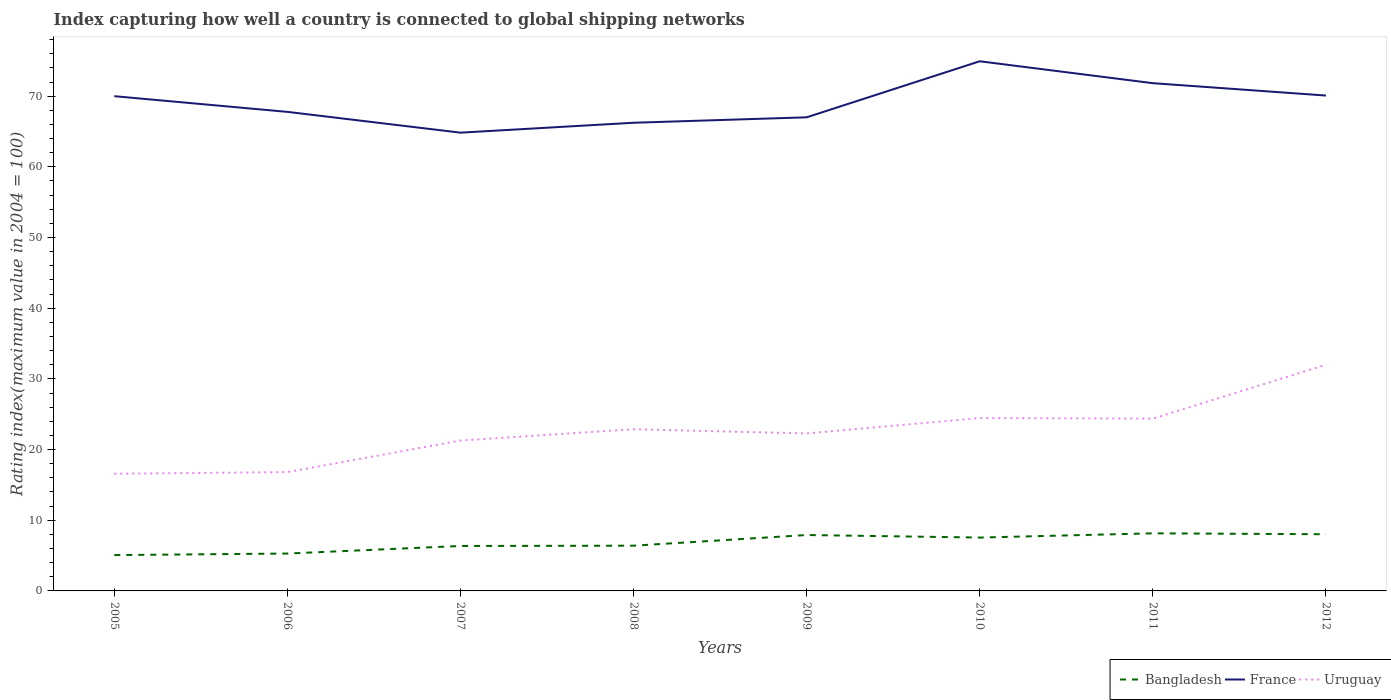Does the line corresponding to Bangladesh intersect with the line corresponding to Uruguay?
Your response must be concise. No. Across all years, what is the maximum rating index in France?
Your response must be concise. 64.84. In which year was the rating index in Bangladesh maximum?
Provide a short and direct response. 2005. What is the total rating index in France in the graph?
Provide a succinct answer. -7. What is the difference between the highest and the second highest rating index in Bangladesh?
Your answer should be compact. 3.08. How many years are there in the graph?
Your answer should be very brief. 8. Are the values on the major ticks of Y-axis written in scientific E-notation?
Keep it short and to the point. No. Does the graph contain any zero values?
Provide a short and direct response. No. Does the graph contain grids?
Provide a short and direct response. No. How many legend labels are there?
Your answer should be compact. 3. How are the legend labels stacked?
Offer a very short reply. Horizontal. What is the title of the graph?
Keep it short and to the point. Index capturing how well a country is connected to global shipping networks. What is the label or title of the X-axis?
Your answer should be very brief. Years. What is the label or title of the Y-axis?
Ensure brevity in your answer.  Rating index(maximum value in 2004 = 100). What is the Rating index(maximum value in 2004 = 100) in Bangladesh in 2005?
Make the answer very short. 5.07. What is the Rating index(maximum value in 2004 = 100) of Uruguay in 2005?
Give a very brief answer. 16.58. What is the Rating index(maximum value in 2004 = 100) in Bangladesh in 2006?
Keep it short and to the point. 5.29. What is the Rating index(maximum value in 2004 = 100) in France in 2006?
Your answer should be very brief. 67.78. What is the Rating index(maximum value in 2004 = 100) in Uruguay in 2006?
Your answer should be compact. 16.81. What is the Rating index(maximum value in 2004 = 100) of Bangladesh in 2007?
Give a very brief answer. 6.36. What is the Rating index(maximum value in 2004 = 100) of France in 2007?
Ensure brevity in your answer.  64.84. What is the Rating index(maximum value in 2004 = 100) of Uruguay in 2007?
Your answer should be very brief. 21.28. What is the Rating index(maximum value in 2004 = 100) of Bangladesh in 2008?
Ensure brevity in your answer.  6.4. What is the Rating index(maximum value in 2004 = 100) in France in 2008?
Give a very brief answer. 66.24. What is the Rating index(maximum value in 2004 = 100) in Uruguay in 2008?
Ensure brevity in your answer.  22.88. What is the Rating index(maximum value in 2004 = 100) of Bangladesh in 2009?
Your answer should be very brief. 7.91. What is the Rating index(maximum value in 2004 = 100) in France in 2009?
Your response must be concise. 67.01. What is the Rating index(maximum value in 2004 = 100) of Uruguay in 2009?
Give a very brief answer. 22.28. What is the Rating index(maximum value in 2004 = 100) in Bangladesh in 2010?
Your response must be concise. 7.55. What is the Rating index(maximum value in 2004 = 100) in France in 2010?
Your response must be concise. 74.94. What is the Rating index(maximum value in 2004 = 100) in Uruguay in 2010?
Your answer should be very brief. 24.46. What is the Rating index(maximum value in 2004 = 100) in Bangladesh in 2011?
Your answer should be very brief. 8.15. What is the Rating index(maximum value in 2004 = 100) of France in 2011?
Your answer should be very brief. 71.84. What is the Rating index(maximum value in 2004 = 100) of Uruguay in 2011?
Keep it short and to the point. 24.38. What is the Rating index(maximum value in 2004 = 100) of Bangladesh in 2012?
Give a very brief answer. 8.02. What is the Rating index(maximum value in 2004 = 100) in France in 2012?
Offer a terse response. 70.09. Across all years, what is the maximum Rating index(maximum value in 2004 = 100) in Bangladesh?
Give a very brief answer. 8.15. Across all years, what is the maximum Rating index(maximum value in 2004 = 100) in France?
Provide a short and direct response. 74.94. Across all years, what is the maximum Rating index(maximum value in 2004 = 100) in Uruguay?
Make the answer very short. 32. Across all years, what is the minimum Rating index(maximum value in 2004 = 100) of Bangladesh?
Give a very brief answer. 5.07. Across all years, what is the minimum Rating index(maximum value in 2004 = 100) in France?
Offer a very short reply. 64.84. Across all years, what is the minimum Rating index(maximum value in 2004 = 100) in Uruguay?
Give a very brief answer. 16.58. What is the total Rating index(maximum value in 2004 = 100) in Bangladesh in the graph?
Keep it short and to the point. 54.75. What is the total Rating index(maximum value in 2004 = 100) in France in the graph?
Provide a short and direct response. 552.74. What is the total Rating index(maximum value in 2004 = 100) in Uruguay in the graph?
Offer a terse response. 180.67. What is the difference between the Rating index(maximum value in 2004 = 100) in Bangladesh in 2005 and that in 2006?
Offer a very short reply. -0.22. What is the difference between the Rating index(maximum value in 2004 = 100) of France in 2005 and that in 2006?
Provide a succinct answer. 2.22. What is the difference between the Rating index(maximum value in 2004 = 100) in Uruguay in 2005 and that in 2006?
Make the answer very short. -0.23. What is the difference between the Rating index(maximum value in 2004 = 100) of Bangladesh in 2005 and that in 2007?
Your response must be concise. -1.29. What is the difference between the Rating index(maximum value in 2004 = 100) of France in 2005 and that in 2007?
Offer a very short reply. 5.16. What is the difference between the Rating index(maximum value in 2004 = 100) in Bangladesh in 2005 and that in 2008?
Offer a terse response. -1.33. What is the difference between the Rating index(maximum value in 2004 = 100) of France in 2005 and that in 2008?
Your answer should be compact. 3.76. What is the difference between the Rating index(maximum value in 2004 = 100) in Uruguay in 2005 and that in 2008?
Provide a short and direct response. -6.3. What is the difference between the Rating index(maximum value in 2004 = 100) in Bangladesh in 2005 and that in 2009?
Keep it short and to the point. -2.84. What is the difference between the Rating index(maximum value in 2004 = 100) of France in 2005 and that in 2009?
Give a very brief answer. 2.99. What is the difference between the Rating index(maximum value in 2004 = 100) of Bangladesh in 2005 and that in 2010?
Your answer should be compact. -2.48. What is the difference between the Rating index(maximum value in 2004 = 100) in France in 2005 and that in 2010?
Your answer should be compact. -4.94. What is the difference between the Rating index(maximum value in 2004 = 100) in Uruguay in 2005 and that in 2010?
Keep it short and to the point. -7.88. What is the difference between the Rating index(maximum value in 2004 = 100) of Bangladesh in 2005 and that in 2011?
Make the answer very short. -3.08. What is the difference between the Rating index(maximum value in 2004 = 100) in France in 2005 and that in 2011?
Keep it short and to the point. -1.84. What is the difference between the Rating index(maximum value in 2004 = 100) of Uruguay in 2005 and that in 2011?
Give a very brief answer. -7.8. What is the difference between the Rating index(maximum value in 2004 = 100) of Bangladesh in 2005 and that in 2012?
Offer a very short reply. -2.95. What is the difference between the Rating index(maximum value in 2004 = 100) of France in 2005 and that in 2012?
Your answer should be compact. -0.09. What is the difference between the Rating index(maximum value in 2004 = 100) of Uruguay in 2005 and that in 2012?
Offer a very short reply. -15.42. What is the difference between the Rating index(maximum value in 2004 = 100) in Bangladesh in 2006 and that in 2007?
Make the answer very short. -1.07. What is the difference between the Rating index(maximum value in 2004 = 100) in France in 2006 and that in 2007?
Offer a terse response. 2.94. What is the difference between the Rating index(maximum value in 2004 = 100) of Uruguay in 2006 and that in 2007?
Your response must be concise. -4.47. What is the difference between the Rating index(maximum value in 2004 = 100) of Bangladesh in 2006 and that in 2008?
Provide a short and direct response. -1.11. What is the difference between the Rating index(maximum value in 2004 = 100) of France in 2006 and that in 2008?
Your answer should be very brief. 1.54. What is the difference between the Rating index(maximum value in 2004 = 100) of Uruguay in 2006 and that in 2008?
Your response must be concise. -6.07. What is the difference between the Rating index(maximum value in 2004 = 100) of Bangladesh in 2006 and that in 2009?
Ensure brevity in your answer.  -2.62. What is the difference between the Rating index(maximum value in 2004 = 100) in France in 2006 and that in 2009?
Your answer should be compact. 0.77. What is the difference between the Rating index(maximum value in 2004 = 100) in Uruguay in 2006 and that in 2009?
Offer a terse response. -5.47. What is the difference between the Rating index(maximum value in 2004 = 100) of Bangladesh in 2006 and that in 2010?
Make the answer very short. -2.26. What is the difference between the Rating index(maximum value in 2004 = 100) in France in 2006 and that in 2010?
Provide a short and direct response. -7.16. What is the difference between the Rating index(maximum value in 2004 = 100) of Uruguay in 2006 and that in 2010?
Keep it short and to the point. -7.65. What is the difference between the Rating index(maximum value in 2004 = 100) of Bangladesh in 2006 and that in 2011?
Offer a terse response. -2.86. What is the difference between the Rating index(maximum value in 2004 = 100) in France in 2006 and that in 2011?
Ensure brevity in your answer.  -4.06. What is the difference between the Rating index(maximum value in 2004 = 100) in Uruguay in 2006 and that in 2011?
Your response must be concise. -7.57. What is the difference between the Rating index(maximum value in 2004 = 100) of Bangladesh in 2006 and that in 2012?
Make the answer very short. -2.73. What is the difference between the Rating index(maximum value in 2004 = 100) in France in 2006 and that in 2012?
Ensure brevity in your answer.  -2.31. What is the difference between the Rating index(maximum value in 2004 = 100) of Uruguay in 2006 and that in 2012?
Give a very brief answer. -15.19. What is the difference between the Rating index(maximum value in 2004 = 100) in Bangladesh in 2007 and that in 2008?
Your response must be concise. -0.04. What is the difference between the Rating index(maximum value in 2004 = 100) in France in 2007 and that in 2008?
Keep it short and to the point. -1.4. What is the difference between the Rating index(maximum value in 2004 = 100) of Uruguay in 2007 and that in 2008?
Your answer should be compact. -1.6. What is the difference between the Rating index(maximum value in 2004 = 100) in Bangladesh in 2007 and that in 2009?
Provide a succinct answer. -1.55. What is the difference between the Rating index(maximum value in 2004 = 100) in France in 2007 and that in 2009?
Your answer should be compact. -2.17. What is the difference between the Rating index(maximum value in 2004 = 100) in Bangladesh in 2007 and that in 2010?
Offer a terse response. -1.19. What is the difference between the Rating index(maximum value in 2004 = 100) in France in 2007 and that in 2010?
Offer a very short reply. -10.1. What is the difference between the Rating index(maximum value in 2004 = 100) in Uruguay in 2007 and that in 2010?
Keep it short and to the point. -3.18. What is the difference between the Rating index(maximum value in 2004 = 100) of Bangladesh in 2007 and that in 2011?
Your response must be concise. -1.79. What is the difference between the Rating index(maximum value in 2004 = 100) in Bangladesh in 2007 and that in 2012?
Give a very brief answer. -1.66. What is the difference between the Rating index(maximum value in 2004 = 100) in France in 2007 and that in 2012?
Your answer should be compact. -5.25. What is the difference between the Rating index(maximum value in 2004 = 100) in Uruguay in 2007 and that in 2012?
Ensure brevity in your answer.  -10.72. What is the difference between the Rating index(maximum value in 2004 = 100) of Bangladesh in 2008 and that in 2009?
Give a very brief answer. -1.51. What is the difference between the Rating index(maximum value in 2004 = 100) of France in 2008 and that in 2009?
Make the answer very short. -0.77. What is the difference between the Rating index(maximum value in 2004 = 100) of Bangladesh in 2008 and that in 2010?
Make the answer very short. -1.15. What is the difference between the Rating index(maximum value in 2004 = 100) of Uruguay in 2008 and that in 2010?
Offer a very short reply. -1.58. What is the difference between the Rating index(maximum value in 2004 = 100) in Bangladesh in 2008 and that in 2011?
Provide a succinct answer. -1.75. What is the difference between the Rating index(maximum value in 2004 = 100) in Uruguay in 2008 and that in 2011?
Offer a terse response. -1.5. What is the difference between the Rating index(maximum value in 2004 = 100) of Bangladesh in 2008 and that in 2012?
Offer a very short reply. -1.62. What is the difference between the Rating index(maximum value in 2004 = 100) in France in 2008 and that in 2012?
Keep it short and to the point. -3.85. What is the difference between the Rating index(maximum value in 2004 = 100) of Uruguay in 2008 and that in 2012?
Keep it short and to the point. -9.12. What is the difference between the Rating index(maximum value in 2004 = 100) of Bangladesh in 2009 and that in 2010?
Your answer should be very brief. 0.36. What is the difference between the Rating index(maximum value in 2004 = 100) of France in 2009 and that in 2010?
Ensure brevity in your answer.  -7.93. What is the difference between the Rating index(maximum value in 2004 = 100) in Uruguay in 2009 and that in 2010?
Offer a very short reply. -2.18. What is the difference between the Rating index(maximum value in 2004 = 100) in Bangladesh in 2009 and that in 2011?
Your response must be concise. -0.24. What is the difference between the Rating index(maximum value in 2004 = 100) in France in 2009 and that in 2011?
Your answer should be very brief. -4.83. What is the difference between the Rating index(maximum value in 2004 = 100) in Bangladesh in 2009 and that in 2012?
Your answer should be very brief. -0.11. What is the difference between the Rating index(maximum value in 2004 = 100) in France in 2009 and that in 2012?
Your response must be concise. -3.08. What is the difference between the Rating index(maximum value in 2004 = 100) of Uruguay in 2009 and that in 2012?
Give a very brief answer. -9.72. What is the difference between the Rating index(maximum value in 2004 = 100) of Bangladesh in 2010 and that in 2011?
Keep it short and to the point. -0.6. What is the difference between the Rating index(maximum value in 2004 = 100) of France in 2010 and that in 2011?
Ensure brevity in your answer.  3.1. What is the difference between the Rating index(maximum value in 2004 = 100) of Bangladesh in 2010 and that in 2012?
Ensure brevity in your answer.  -0.47. What is the difference between the Rating index(maximum value in 2004 = 100) of France in 2010 and that in 2012?
Provide a succinct answer. 4.85. What is the difference between the Rating index(maximum value in 2004 = 100) of Uruguay in 2010 and that in 2012?
Provide a succinct answer. -7.54. What is the difference between the Rating index(maximum value in 2004 = 100) of Bangladesh in 2011 and that in 2012?
Provide a short and direct response. 0.13. What is the difference between the Rating index(maximum value in 2004 = 100) in France in 2011 and that in 2012?
Ensure brevity in your answer.  1.75. What is the difference between the Rating index(maximum value in 2004 = 100) of Uruguay in 2011 and that in 2012?
Offer a terse response. -7.62. What is the difference between the Rating index(maximum value in 2004 = 100) in Bangladesh in 2005 and the Rating index(maximum value in 2004 = 100) in France in 2006?
Make the answer very short. -62.71. What is the difference between the Rating index(maximum value in 2004 = 100) of Bangladesh in 2005 and the Rating index(maximum value in 2004 = 100) of Uruguay in 2006?
Offer a very short reply. -11.74. What is the difference between the Rating index(maximum value in 2004 = 100) of France in 2005 and the Rating index(maximum value in 2004 = 100) of Uruguay in 2006?
Your answer should be compact. 53.19. What is the difference between the Rating index(maximum value in 2004 = 100) of Bangladesh in 2005 and the Rating index(maximum value in 2004 = 100) of France in 2007?
Make the answer very short. -59.77. What is the difference between the Rating index(maximum value in 2004 = 100) of Bangladesh in 2005 and the Rating index(maximum value in 2004 = 100) of Uruguay in 2007?
Your response must be concise. -16.21. What is the difference between the Rating index(maximum value in 2004 = 100) in France in 2005 and the Rating index(maximum value in 2004 = 100) in Uruguay in 2007?
Your answer should be very brief. 48.72. What is the difference between the Rating index(maximum value in 2004 = 100) of Bangladesh in 2005 and the Rating index(maximum value in 2004 = 100) of France in 2008?
Offer a terse response. -61.17. What is the difference between the Rating index(maximum value in 2004 = 100) in Bangladesh in 2005 and the Rating index(maximum value in 2004 = 100) in Uruguay in 2008?
Make the answer very short. -17.81. What is the difference between the Rating index(maximum value in 2004 = 100) of France in 2005 and the Rating index(maximum value in 2004 = 100) of Uruguay in 2008?
Provide a short and direct response. 47.12. What is the difference between the Rating index(maximum value in 2004 = 100) in Bangladesh in 2005 and the Rating index(maximum value in 2004 = 100) in France in 2009?
Offer a terse response. -61.94. What is the difference between the Rating index(maximum value in 2004 = 100) of Bangladesh in 2005 and the Rating index(maximum value in 2004 = 100) of Uruguay in 2009?
Give a very brief answer. -17.21. What is the difference between the Rating index(maximum value in 2004 = 100) of France in 2005 and the Rating index(maximum value in 2004 = 100) of Uruguay in 2009?
Provide a succinct answer. 47.72. What is the difference between the Rating index(maximum value in 2004 = 100) in Bangladesh in 2005 and the Rating index(maximum value in 2004 = 100) in France in 2010?
Offer a very short reply. -69.87. What is the difference between the Rating index(maximum value in 2004 = 100) of Bangladesh in 2005 and the Rating index(maximum value in 2004 = 100) of Uruguay in 2010?
Offer a very short reply. -19.39. What is the difference between the Rating index(maximum value in 2004 = 100) in France in 2005 and the Rating index(maximum value in 2004 = 100) in Uruguay in 2010?
Ensure brevity in your answer.  45.54. What is the difference between the Rating index(maximum value in 2004 = 100) in Bangladesh in 2005 and the Rating index(maximum value in 2004 = 100) in France in 2011?
Offer a terse response. -66.77. What is the difference between the Rating index(maximum value in 2004 = 100) of Bangladesh in 2005 and the Rating index(maximum value in 2004 = 100) of Uruguay in 2011?
Keep it short and to the point. -19.31. What is the difference between the Rating index(maximum value in 2004 = 100) in France in 2005 and the Rating index(maximum value in 2004 = 100) in Uruguay in 2011?
Your response must be concise. 45.62. What is the difference between the Rating index(maximum value in 2004 = 100) in Bangladesh in 2005 and the Rating index(maximum value in 2004 = 100) in France in 2012?
Provide a succinct answer. -65.02. What is the difference between the Rating index(maximum value in 2004 = 100) of Bangladesh in 2005 and the Rating index(maximum value in 2004 = 100) of Uruguay in 2012?
Your answer should be compact. -26.93. What is the difference between the Rating index(maximum value in 2004 = 100) of Bangladesh in 2006 and the Rating index(maximum value in 2004 = 100) of France in 2007?
Provide a short and direct response. -59.55. What is the difference between the Rating index(maximum value in 2004 = 100) of Bangladesh in 2006 and the Rating index(maximum value in 2004 = 100) of Uruguay in 2007?
Ensure brevity in your answer.  -15.99. What is the difference between the Rating index(maximum value in 2004 = 100) of France in 2006 and the Rating index(maximum value in 2004 = 100) of Uruguay in 2007?
Provide a short and direct response. 46.5. What is the difference between the Rating index(maximum value in 2004 = 100) of Bangladesh in 2006 and the Rating index(maximum value in 2004 = 100) of France in 2008?
Ensure brevity in your answer.  -60.95. What is the difference between the Rating index(maximum value in 2004 = 100) of Bangladesh in 2006 and the Rating index(maximum value in 2004 = 100) of Uruguay in 2008?
Ensure brevity in your answer.  -17.59. What is the difference between the Rating index(maximum value in 2004 = 100) of France in 2006 and the Rating index(maximum value in 2004 = 100) of Uruguay in 2008?
Ensure brevity in your answer.  44.9. What is the difference between the Rating index(maximum value in 2004 = 100) of Bangladesh in 2006 and the Rating index(maximum value in 2004 = 100) of France in 2009?
Make the answer very short. -61.72. What is the difference between the Rating index(maximum value in 2004 = 100) in Bangladesh in 2006 and the Rating index(maximum value in 2004 = 100) in Uruguay in 2009?
Give a very brief answer. -16.99. What is the difference between the Rating index(maximum value in 2004 = 100) of France in 2006 and the Rating index(maximum value in 2004 = 100) of Uruguay in 2009?
Ensure brevity in your answer.  45.5. What is the difference between the Rating index(maximum value in 2004 = 100) in Bangladesh in 2006 and the Rating index(maximum value in 2004 = 100) in France in 2010?
Provide a short and direct response. -69.65. What is the difference between the Rating index(maximum value in 2004 = 100) in Bangladesh in 2006 and the Rating index(maximum value in 2004 = 100) in Uruguay in 2010?
Give a very brief answer. -19.17. What is the difference between the Rating index(maximum value in 2004 = 100) in France in 2006 and the Rating index(maximum value in 2004 = 100) in Uruguay in 2010?
Give a very brief answer. 43.32. What is the difference between the Rating index(maximum value in 2004 = 100) of Bangladesh in 2006 and the Rating index(maximum value in 2004 = 100) of France in 2011?
Make the answer very short. -66.55. What is the difference between the Rating index(maximum value in 2004 = 100) of Bangladesh in 2006 and the Rating index(maximum value in 2004 = 100) of Uruguay in 2011?
Your answer should be compact. -19.09. What is the difference between the Rating index(maximum value in 2004 = 100) of France in 2006 and the Rating index(maximum value in 2004 = 100) of Uruguay in 2011?
Provide a succinct answer. 43.4. What is the difference between the Rating index(maximum value in 2004 = 100) of Bangladesh in 2006 and the Rating index(maximum value in 2004 = 100) of France in 2012?
Your answer should be very brief. -64.8. What is the difference between the Rating index(maximum value in 2004 = 100) in Bangladesh in 2006 and the Rating index(maximum value in 2004 = 100) in Uruguay in 2012?
Provide a succinct answer. -26.71. What is the difference between the Rating index(maximum value in 2004 = 100) of France in 2006 and the Rating index(maximum value in 2004 = 100) of Uruguay in 2012?
Keep it short and to the point. 35.78. What is the difference between the Rating index(maximum value in 2004 = 100) of Bangladesh in 2007 and the Rating index(maximum value in 2004 = 100) of France in 2008?
Provide a succinct answer. -59.88. What is the difference between the Rating index(maximum value in 2004 = 100) of Bangladesh in 2007 and the Rating index(maximum value in 2004 = 100) of Uruguay in 2008?
Provide a succinct answer. -16.52. What is the difference between the Rating index(maximum value in 2004 = 100) of France in 2007 and the Rating index(maximum value in 2004 = 100) of Uruguay in 2008?
Keep it short and to the point. 41.96. What is the difference between the Rating index(maximum value in 2004 = 100) of Bangladesh in 2007 and the Rating index(maximum value in 2004 = 100) of France in 2009?
Your answer should be very brief. -60.65. What is the difference between the Rating index(maximum value in 2004 = 100) of Bangladesh in 2007 and the Rating index(maximum value in 2004 = 100) of Uruguay in 2009?
Offer a terse response. -15.92. What is the difference between the Rating index(maximum value in 2004 = 100) in France in 2007 and the Rating index(maximum value in 2004 = 100) in Uruguay in 2009?
Ensure brevity in your answer.  42.56. What is the difference between the Rating index(maximum value in 2004 = 100) of Bangladesh in 2007 and the Rating index(maximum value in 2004 = 100) of France in 2010?
Give a very brief answer. -68.58. What is the difference between the Rating index(maximum value in 2004 = 100) in Bangladesh in 2007 and the Rating index(maximum value in 2004 = 100) in Uruguay in 2010?
Offer a terse response. -18.1. What is the difference between the Rating index(maximum value in 2004 = 100) of France in 2007 and the Rating index(maximum value in 2004 = 100) of Uruguay in 2010?
Offer a very short reply. 40.38. What is the difference between the Rating index(maximum value in 2004 = 100) in Bangladesh in 2007 and the Rating index(maximum value in 2004 = 100) in France in 2011?
Offer a terse response. -65.48. What is the difference between the Rating index(maximum value in 2004 = 100) of Bangladesh in 2007 and the Rating index(maximum value in 2004 = 100) of Uruguay in 2011?
Provide a succinct answer. -18.02. What is the difference between the Rating index(maximum value in 2004 = 100) in France in 2007 and the Rating index(maximum value in 2004 = 100) in Uruguay in 2011?
Provide a succinct answer. 40.46. What is the difference between the Rating index(maximum value in 2004 = 100) of Bangladesh in 2007 and the Rating index(maximum value in 2004 = 100) of France in 2012?
Your response must be concise. -63.73. What is the difference between the Rating index(maximum value in 2004 = 100) in Bangladesh in 2007 and the Rating index(maximum value in 2004 = 100) in Uruguay in 2012?
Make the answer very short. -25.64. What is the difference between the Rating index(maximum value in 2004 = 100) of France in 2007 and the Rating index(maximum value in 2004 = 100) of Uruguay in 2012?
Your answer should be compact. 32.84. What is the difference between the Rating index(maximum value in 2004 = 100) in Bangladesh in 2008 and the Rating index(maximum value in 2004 = 100) in France in 2009?
Your response must be concise. -60.61. What is the difference between the Rating index(maximum value in 2004 = 100) in Bangladesh in 2008 and the Rating index(maximum value in 2004 = 100) in Uruguay in 2009?
Provide a short and direct response. -15.88. What is the difference between the Rating index(maximum value in 2004 = 100) of France in 2008 and the Rating index(maximum value in 2004 = 100) of Uruguay in 2009?
Keep it short and to the point. 43.96. What is the difference between the Rating index(maximum value in 2004 = 100) in Bangladesh in 2008 and the Rating index(maximum value in 2004 = 100) in France in 2010?
Keep it short and to the point. -68.54. What is the difference between the Rating index(maximum value in 2004 = 100) of Bangladesh in 2008 and the Rating index(maximum value in 2004 = 100) of Uruguay in 2010?
Provide a short and direct response. -18.06. What is the difference between the Rating index(maximum value in 2004 = 100) in France in 2008 and the Rating index(maximum value in 2004 = 100) in Uruguay in 2010?
Ensure brevity in your answer.  41.78. What is the difference between the Rating index(maximum value in 2004 = 100) in Bangladesh in 2008 and the Rating index(maximum value in 2004 = 100) in France in 2011?
Provide a short and direct response. -65.44. What is the difference between the Rating index(maximum value in 2004 = 100) in Bangladesh in 2008 and the Rating index(maximum value in 2004 = 100) in Uruguay in 2011?
Your answer should be very brief. -17.98. What is the difference between the Rating index(maximum value in 2004 = 100) in France in 2008 and the Rating index(maximum value in 2004 = 100) in Uruguay in 2011?
Your answer should be very brief. 41.86. What is the difference between the Rating index(maximum value in 2004 = 100) in Bangladesh in 2008 and the Rating index(maximum value in 2004 = 100) in France in 2012?
Ensure brevity in your answer.  -63.69. What is the difference between the Rating index(maximum value in 2004 = 100) of Bangladesh in 2008 and the Rating index(maximum value in 2004 = 100) of Uruguay in 2012?
Give a very brief answer. -25.6. What is the difference between the Rating index(maximum value in 2004 = 100) in France in 2008 and the Rating index(maximum value in 2004 = 100) in Uruguay in 2012?
Ensure brevity in your answer.  34.24. What is the difference between the Rating index(maximum value in 2004 = 100) in Bangladesh in 2009 and the Rating index(maximum value in 2004 = 100) in France in 2010?
Offer a very short reply. -67.03. What is the difference between the Rating index(maximum value in 2004 = 100) of Bangladesh in 2009 and the Rating index(maximum value in 2004 = 100) of Uruguay in 2010?
Your response must be concise. -16.55. What is the difference between the Rating index(maximum value in 2004 = 100) of France in 2009 and the Rating index(maximum value in 2004 = 100) of Uruguay in 2010?
Offer a terse response. 42.55. What is the difference between the Rating index(maximum value in 2004 = 100) in Bangladesh in 2009 and the Rating index(maximum value in 2004 = 100) in France in 2011?
Your response must be concise. -63.93. What is the difference between the Rating index(maximum value in 2004 = 100) in Bangladesh in 2009 and the Rating index(maximum value in 2004 = 100) in Uruguay in 2011?
Your answer should be very brief. -16.47. What is the difference between the Rating index(maximum value in 2004 = 100) in France in 2009 and the Rating index(maximum value in 2004 = 100) in Uruguay in 2011?
Offer a terse response. 42.63. What is the difference between the Rating index(maximum value in 2004 = 100) in Bangladesh in 2009 and the Rating index(maximum value in 2004 = 100) in France in 2012?
Offer a terse response. -62.18. What is the difference between the Rating index(maximum value in 2004 = 100) of Bangladesh in 2009 and the Rating index(maximum value in 2004 = 100) of Uruguay in 2012?
Make the answer very short. -24.09. What is the difference between the Rating index(maximum value in 2004 = 100) in France in 2009 and the Rating index(maximum value in 2004 = 100) in Uruguay in 2012?
Offer a terse response. 35.01. What is the difference between the Rating index(maximum value in 2004 = 100) of Bangladesh in 2010 and the Rating index(maximum value in 2004 = 100) of France in 2011?
Give a very brief answer. -64.29. What is the difference between the Rating index(maximum value in 2004 = 100) in Bangladesh in 2010 and the Rating index(maximum value in 2004 = 100) in Uruguay in 2011?
Your answer should be compact. -16.83. What is the difference between the Rating index(maximum value in 2004 = 100) of France in 2010 and the Rating index(maximum value in 2004 = 100) of Uruguay in 2011?
Provide a succinct answer. 50.56. What is the difference between the Rating index(maximum value in 2004 = 100) in Bangladesh in 2010 and the Rating index(maximum value in 2004 = 100) in France in 2012?
Offer a very short reply. -62.54. What is the difference between the Rating index(maximum value in 2004 = 100) of Bangladesh in 2010 and the Rating index(maximum value in 2004 = 100) of Uruguay in 2012?
Provide a succinct answer. -24.45. What is the difference between the Rating index(maximum value in 2004 = 100) in France in 2010 and the Rating index(maximum value in 2004 = 100) in Uruguay in 2012?
Keep it short and to the point. 42.94. What is the difference between the Rating index(maximum value in 2004 = 100) in Bangladesh in 2011 and the Rating index(maximum value in 2004 = 100) in France in 2012?
Offer a very short reply. -61.94. What is the difference between the Rating index(maximum value in 2004 = 100) of Bangladesh in 2011 and the Rating index(maximum value in 2004 = 100) of Uruguay in 2012?
Provide a succinct answer. -23.85. What is the difference between the Rating index(maximum value in 2004 = 100) of France in 2011 and the Rating index(maximum value in 2004 = 100) of Uruguay in 2012?
Provide a succinct answer. 39.84. What is the average Rating index(maximum value in 2004 = 100) in Bangladesh per year?
Make the answer very short. 6.84. What is the average Rating index(maximum value in 2004 = 100) in France per year?
Keep it short and to the point. 69.09. What is the average Rating index(maximum value in 2004 = 100) in Uruguay per year?
Offer a very short reply. 22.58. In the year 2005, what is the difference between the Rating index(maximum value in 2004 = 100) in Bangladesh and Rating index(maximum value in 2004 = 100) in France?
Your answer should be compact. -64.93. In the year 2005, what is the difference between the Rating index(maximum value in 2004 = 100) of Bangladesh and Rating index(maximum value in 2004 = 100) of Uruguay?
Ensure brevity in your answer.  -11.51. In the year 2005, what is the difference between the Rating index(maximum value in 2004 = 100) in France and Rating index(maximum value in 2004 = 100) in Uruguay?
Offer a terse response. 53.42. In the year 2006, what is the difference between the Rating index(maximum value in 2004 = 100) of Bangladesh and Rating index(maximum value in 2004 = 100) of France?
Offer a terse response. -62.49. In the year 2006, what is the difference between the Rating index(maximum value in 2004 = 100) of Bangladesh and Rating index(maximum value in 2004 = 100) of Uruguay?
Keep it short and to the point. -11.52. In the year 2006, what is the difference between the Rating index(maximum value in 2004 = 100) of France and Rating index(maximum value in 2004 = 100) of Uruguay?
Ensure brevity in your answer.  50.97. In the year 2007, what is the difference between the Rating index(maximum value in 2004 = 100) of Bangladesh and Rating index(maximum value in 2004 = 100) of France?
Provide a succinct answer. -58.48. In the year 2007, what is the difference between the Rating index(maximum value in 2004 = 100) in Bangladesh and Rating index(maximum value in 2004 = 100) in Uruguay?
Give a very brief answer. -14.92. In the year 2007, what is the difference between the Rating index(maximum value in 2004 = 100) in France and Rating index(maximum value in 2004 = 100) in Uruguay?
Your answer should be compact. 43.56. In the year 2008, what is the difference between the Rating index(maximum value in 2004 = 100) in Bangladesh and Rating index(maximum value in 2004 = 100) in France?
Provide a short and direct response. -59.84. In the year 2008, what is the difference between the Rating index(maximum value in 2004 = 100) of Bangladesh and Rating index(maximum value in 2004 = 100) of Uruguay?
Your answer should be very brief. -16.48. In the year 2008, what is the difference between the Rating index(maximum value in 2004 = 100) in France and Rating index(maximum value in 2004 = 100) in Uruguay?
Your answer should be very brief. 43.36. In the year 2009, what is the difference between the Rating index(maximum value in 2004 = 100) of Bangladesh and Rating index(maximum value in 2004 = 100) of France?
Your answer should be compact. -59.1. In the year 2009, what is the difference between the Rating index(maximum value in 2004 = 100) in Bangladesh and Rating index(maximum value in 2004 = 100) in Uruguay?
Your answer should be compact. -14.37. In the year 2009, what is the difference between the Rating index(maximum value in 2004 = 100) of France and Rating index(maximum value in 2004 = 100) of Uruguay?
Make the answer very short. 44.73. In the year 2010, what is the difference between the Rating index(maximum value in 2004 = 100) of Bangladesh and Rating index(maximum value in 2004 = 100) of France?
Provide a short and direct response. -67.39. In the year 2010, what is the difference between the Rating index(maximum value in 2004 = 100) in Bangladesh and Rating index(maximum value in 2004 = 100) in Uruguay?
Provide a short and direct response. -16.91. In the year 2010, what is the difference between the Rating index(maximum value in 2004 = 100) of France and Rating index(maximum value in 2004 = 100) of Uruguay?
Offer a very short reply. 50.48. In the year 2011, what is the difference between the Rating index(maximum value in 2004 = 100) of Bangladesh and Rating index(maximum value in 2004 = 100) of France?
Ensure brevity in your answer.  -63.69. In the year 2011, what is the difference between the Rating index(maximum value in 2004 = 100) of Bangladesh and Rating index(maximum value in 2004 = 100) of Uruguay?
Your response must be concise. -16.23. In the year 2011, what is the difference between the Rating index(maximum value in 2004 = 100) of France and Rating index(maximum value in 2004 = 100) of Uruguay?
Provide a succinct answer. 47.46. In the year 2012, what is the difference between the Rating index(maximum value in 2004 = 100) of Bangladesh and Rating index(maximum value in 2004 = 100) of France?
Make the answer very short. -62.07. In the year 2012, what is the difference between the Rating index(maximum value in 2004 = 100) in Bangladesh and Rating index(maximum value in 2004 = 100) in Uruguay?
Give a very brief answer. -23.98. In the year 2012, what is the difference between the Rating index(maximum value in 2004 = 100) in France and Rating index(maximum value in 2004 = 100) in Uruguay?
Give a very brief answer. 38.09. What is the ratio of the Rating index(maximum value in 2004 = 100) of Bangladesh in 2005 to that in 2006?
Ensure brevity in your answer.  0.96. What is the ratio of the Rating index(maximum value in 2004 = 100) of France in 2005 to that in 2006?
Provide a succinct answer. 1.03. What is the ratio of the Rating index(maximum value in 2004 = 100) in Uruguay in 2005 to that in 2006?
Provide a succinct answer. 0.99. What is the ratio of the Rating index(maximum value in 2004 = 100) of Bangladesh in 2005 to that in 2007?
Ensure brevity in your answer.  0.8. What is the ratio of the Rating index(maximum value in 2004 = 100) of France in 2005 to that in 2007?
Offer a terse response. 1.08. What is the ratio of the Rating index(maximum value in 2004 = 100) of Uruguay in 2005 to that in 2007?
Keep it short and to the point. 0.78. What is the ratio of the Rating index(maximum value in 2004 = 100) of Bangladesh in 2005 to that in 2008?
Your response must be concise. 0.79. What is the ratio of the Rating index(maximum value in 2004 = 100) of France in 2005 to that in 2008?
Give a very brief answer. 1.06. What is the ratio of the Rating index(maximum value in 2004 = 100) of Uruguay in 2005 to that in 2008?
Offer a terse response. 0.72. What is the ratio of the Rating index(maximum value in 2004 = 100) of Bangladesh in 2005 to that in 2009?
Your answer should be very brief. 0.64. What is the ratio of the Rating index(maximum value in 2004 = 100) in France in 2005 to that in 2009?
Provide a succinct answer. 1.04. What is the ratio of the Rating index(maximum value in 2004 = 100) of Uruguay in 2005 to that in 2009?
Ensure brevity in your answer.  0.74. What is the ratio of the Rating index(maximum value in 2004 = 100) in Bangladesh in 2005 to that in 2010?
Give a very brief answer. 0.67. What is the ratio of the Rating index(maximum value in 2004 = 100) of France in 2005 to that in 2010?
Give a very brief answer. 0.93. What is the ratio of the Rating index(maximum value in 2004 = 100) in Uruguay in 2005 to that in 2010?
Give a very brief answer. 0.68. What is the ratio of the Rating index(maximum value in 2004 = 100) of Bangladesh in 2005 to that in 2011?
Offer a terse response. 0.62. What is the ratio of the Rating index(maximum value in 2004 = 100) in France in 2005 to that in 2011?
Offer a terse response. 0.97. What is the ratio of the Rating index(maximum value in 2004 = 100) of Uruguay in 2005 to that in 2011?
Offer a very short reply. 0.68. What is the ratio of the Rating index(maximum value in 2004 = 100) in Bangladesh in 2005 to that in 2012?
Make the answer very short. 0.63. What is the ratio of the Rating index(maximum value in 2004 = 100) of Uruguay in 2005 to that in 2012?
Offer a terse response. 0.52. What is the ratio of the Rating index(maximum value in 2004 = 100) of Bangladesh in 2006 to that in 2007?
Your response must be concise. 0.83. What is the ratio of the Rating index(maximum value in 2004 = 100) in France in 2006 to that in 2007?
Give a very brief answer. 1.05. What is the ratio of the Rating index(maximum value in 2004 = 100) of Uruguay in 2006 to that in 2007?
Provide a short and direct response. 0.79. What is the ratio of the Rating index(maximum value in 2004 = 100) of Bangladesh in 2006 to that in 2008?
Offer a terse response. 0.83. What is the ratio of the Rating index(maximum value in 2004 = 100) of France in 2006 to that in 2008?
Keep it short and to the point. 1.02. What is the ratio of the Rating index(maximum value in 2004 = 100) of Uruguay in 2006 to that in 2008?
Keep it short and to the point. 0.73. What is the ratio of the Rating index(maximum value in 2004 = 100) in Bangladesh in 2006 to that in 2009?
Provide a succinct answer. 0.67. What is the ratio of the Rating index(maximum value in 2004 = 100) of France in 2006 to that in 2009?
Your answer should be compact. 1.01. What is the ratio of the Rating index(maximum value in 2004 = 100) in Uruguay in 2006 to that in 2009?
Keep it short and to the point. 0.75. What is the ratio of the Rating index(maximum value in 2004 = 100) of Bangladesh in 2006 to that in 2010?
Offer a very short reply. 0.7. What is the ratio of the Rating index(maximum value in 2004 = 100) in France in 2006 to that in 2010?
Provide a short and direct response. 0.9. What is the ratio of the Rating index(maximum value in 2004 = 100) of Uruguay in 2006 to that in 2010?
Offer a terse response. 0.69. What is the ratio of the Rating index(maximum value in 2004 = 100) in Bangladesh in 2006 to that in 2011?
Provide a succinct answer. 0.65. What is the ratio of the Rating index(maximum value in 2004 = 100) of France in 2006 to that in 2011?
Your response must be concise. 0.94. What is the ratio of the Rating index(maximum value in 2004 = 100) in Uruguay in 2006 to that in 2011?
Your answer should be compact. 0.69. What is the ratio of the Rating index(maximum value in 2004 = 100) of Bangladesh in 2006 to that in 2012?
Your answer should be very brief. 0.66. What is the ratio of the Rating index(maximum value in 2004 = 100) of France in 2006 to that in 2012?
Offer a terse response. 0.97. What is the ratio of the Rating index(maximum value in 2004 = 100) in Uruguay in 2006 to that in 2012?
Offer a terse response. 0.53. What is the ratio of the Rating index(maximum value in 2004 = 100) in Bangladesh in 2007 to that in 2008?
Your answer should be compact. 0.99. What is the ratio of the Rating index(maximum value in 2004 = 100) of France in 2007 to that in 2008?
Your answer should be very brief. 0.98. What is the ratio of the Rating index(maximum value in 2004 = 100) in Uruguay in 2007 to that in 2008?
Your response must be concise. 0.93. What is the ratio of the Rating index(maximum value in 2004 = 100) of Bangladesh in 2007 to that in 2009?
Your answer should be very brief. 0.8. What is the ratio of the Rating index(maximum value in 2004 = 100) of France in 2007 to that in 2009?
Ensure brevity in your answer.  0.97. What is the ratio of the Rating index(maximum value in 2004 = 100) of Uruguay in 2007 to that in 2009?
Offer a very short reply. 0.96. What is the ratio of the Rating index(maximum value in 2004 = 100) in Bangladesh in 2007 to that in 2010?
Your answer should be very brief. 0.84. What is the ratio of the Rating index(maximum value in 2004 = 100) in France in 2007 to that in 2010?
Your answer should be very brief. 0.87. What is the ratio of the Rating index(maximum value in 2004 = 100) in Uruguay in 2007 to that in 2010?
Make the answer very short. 0.87. What is the ratio of the Rating index(maximum value in 2004 = 100) of Bangladesh in 2007 to that in 2011?
Provide a succinct answer. 0.78. What is the ratio of the Rating index(maximum value in 2004 = 100) in France in 2007 to that in 2011?
Keep it short and to the point. 0.9. What is the ratio of the Rating index(maximum value in 2004 = 100) in Uruguay in 2007 to that in 2011?
Give a very brief answer. 0.87. What is the ratio of the Rating index(maximum value in 2004 = 100) of Bangladesh in 2007 to that in 2012?
Keep it short and to the point. 0.79. What is the ratio of the Rating index(maximum value in 2004 = 100) of France in 2007 to that in 2012?
Make the answer very short. 0.93. What is the ratio of the Rating index(maximum value in 2004 = 100) of Uruguay in 2007 to that in 2012?
Your answer should be very brief. 0.67. What is the ratio of the Rating index(maximum value in 2004 = 100) in Bangladesh in 2008 to that in 2009?
Keep it short and to the point. 0.81. What is the ratio of the Rating index(maximum value in 2004 = 100) in France in 2008 to that in 2009?
Keep it short and to the point. 0.99. What is the ratio of the Rating index(maximum value in 2004 = 100) in Uruguay in 2008 to that in 2009?
Offer a terse response. 1.03. What is the ratio of the Rating index(maximum value in 2004 = 100) of Bangladesh in 2008 to that in 2010?
Ensure brevity in your answer.  0.85. What is the ratio of the Rating index(maximum value in 2004 = 100) in France in 2008 to that in 2010?
Ensure brevity in your answer.  0.88. What is the ratio of the Rating index(maximum value in 2004 = 100) of Uruguay in 2008 to that in 2010?
Your response must be concise. 0.94. What is the ratio of the Rating index(maximum value in 2004 = 100) of Bangladesh in 2008 to that in 2011?
Your answer should be very brief. 0.79. What is the ratio of the Rating index(maximum value in 2004 = 100) of France in 2008 to that in 2011?
Your answer should be very brief. 0.92. What is the ratio of the Rating index(maximum value in 2004 = 100) of Uruguay in 2008 to that in 2011?
Offer a very short reply. 0.94. What is the ratio of the Rating index(maximum value in 2004 = 100) of Bangladesh in 2008 to that in 2012?
Your answer should be compact. 0.8. What is the ratio of the Rating index(maximum value in 2004 = 100) in France in 2008 to that in 2012?
Keep it short and to the point. 0.95. What is the ratio of the Rating index(maximum value in 2004 = 100) of Uruguay in 2008 to that in 2012?
Your answer should be very brief. 0.71. What is the ratio of the Rating index(maximum value in 2004 = 100) of Bangladesh in 2009 to that in 2010?
Offer a very short reply. 1.05. What is the ratio of the Rating index(maximum value in 2004 = 100) in France in 2009 to that in 2010?
Ensure brevity in your answer.  0.89. What is the ratio of the Rating index(maximum value in 2004 = 100) of Uruguay in 2009 to that in 2010?
Your answer should be compact. 0.91. What is the ratio of the Rating index(maximum value in 2004 = 100) of Bangladesh in 2009 to that in 2011?
Offer a very short reply. 0.97. What is the ratio of the Rating index(maximum value in 2004 = 100) in France in 2009 to that in 2011?
Offer a very short reply. 0.93. What is the ratio of the Rating index(maximum value in 2004 = 100) in Uruguay in 2009 to that in 2011?
Offer a very short reply. 0.91. What is the ratio of the Rating index(maximum value in 2004 = 100) of Bangladesh in 2009 to that in 2012?
Provide a short and direct response. 0.99. What is the ratio of the Rating index(maximum value in 2004 = 100) of France in 2009 to that in 2012?
Keep it short and to the point. 0.96. What is the ratio of the Rating index(maximum value in 2004 = 100) of Uruguay in 2009 to that in 2012?
Offer a terse response. 0.7. What is the ratio of the Rating index(maximum value in 2004 = 100) of Bangladesh in 2010 to that in 2011?
Provide a short and direct response. 0.93. What is the ratio of the Rating index(maximum value in 2004 = 100) of France in 2010 to that in 2011?
Your response must be concise. 1.04. What is the ratio of the Rating index(maximum value in 2004 = 100) of Bangladesh in 2010 to that in 2012?
Provide a succinct answer. 0.94. What is the ratio of the Rating index(maximum value in 2004 = 100) of France in 2010 to that in 2012?
Offer a very short reply. 1.07. What is the ratio of the Rating index(maximum value in 2004 = 100) in Uruguay in 2010 to that in 2012?
Give a very brief answer. 0.76. What is the ratio of the Rating index(maximum value in 2004 = 100) of Bangladesh in 2011 to that in 2012?
Offer a very short reply. 1.02. What is the ratio of the Rating index(maximum value in 2004 = 100) in Uruguay in 2011 to that in 2012?
Make the answer very short. 0.76. What is the difference between the highest and the second highest Rating index(maximum value in 2004 = 100) in Bangladesh?
Your response must be concise. 0.13. What is the difference between the highest and the second highest Rating index(maximum value in 2004 = 100) in Uruguay?
Keep it short and to the point. 7.54. What is the difference between the highest and the lowest Rating index(maximum value in 2004 = 100) of Bangladesh?
Give a very brief answer. 3.08. What is the difference between the highest and the lowest Rating index(maximum value in 2004 = 100) in Uruguay?
Keep it short and to the point. 15.42. 